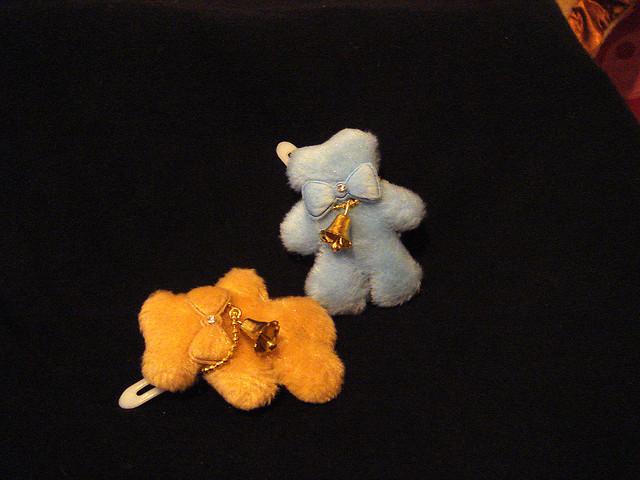What is on the table?
Be succinct. Stuffed bears. How many bells?
Short answer required. 2. What season would these items most likely be used for?
Short answer required. Christmas. 